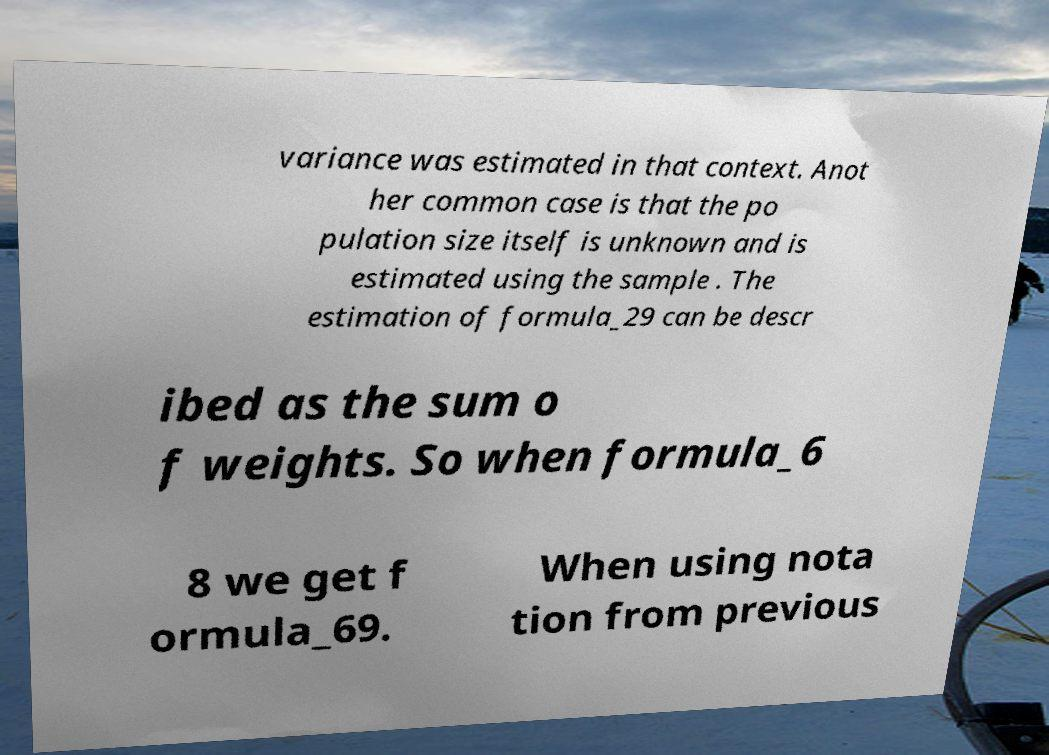Please identify and transcribe the text found in this image. variance was estimated in that context. Anot her common case is that the po pulation size itself is unknown and is estimated using the sample . The estimation of formula_29 can be descr ibed as the sum o f weights. So when formula_6 8 we get f ormula_69. When using nota tion from previous 